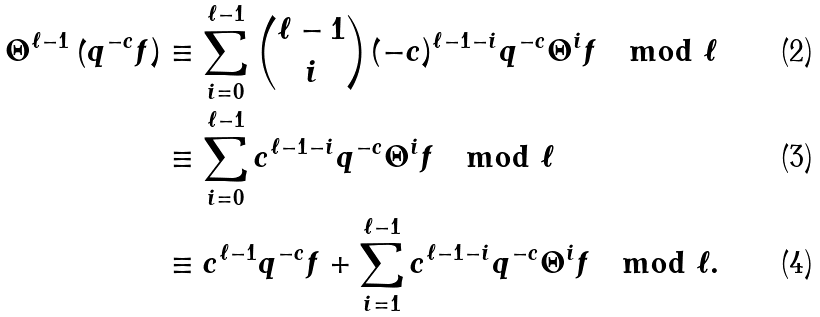Convert formula to latex. <formula><loc_0><loc_0><loc_500><loc_500>\Theta ^ { \ell - 1 } \left ( q ^ { - c } f \right ) & \equiv \sum _ { i = 0 } ^ { \ell - 1 } \binom { \ell - 1 } { i } ( - c ) ^ { \ell - 1 - i } q ^ { - c } \Theta ^ { i } f \mod \ell \\ & \equiv \sum _ { i = 0 } ^ { \ell - 1 } c ^ { \ell - 1 - i } q ^ { - c } \Theta ^ { i } f \mod \ell \\ & \equiv c ^ { \ell - 1 } q ^ { - c } f + \sum _ { i = 1 } ^ { \ell - 1 } c ^ { \ell - 1 - i } q ^ { - c } \Theta ^ { i } f \mod \ell .</formula> 